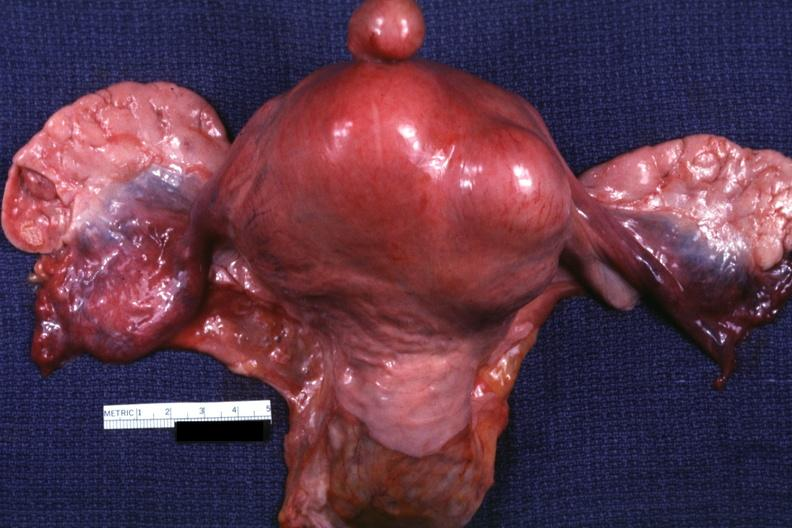where does this part belong to?
Answer the question using a single word or phrase. Female reproductive system 